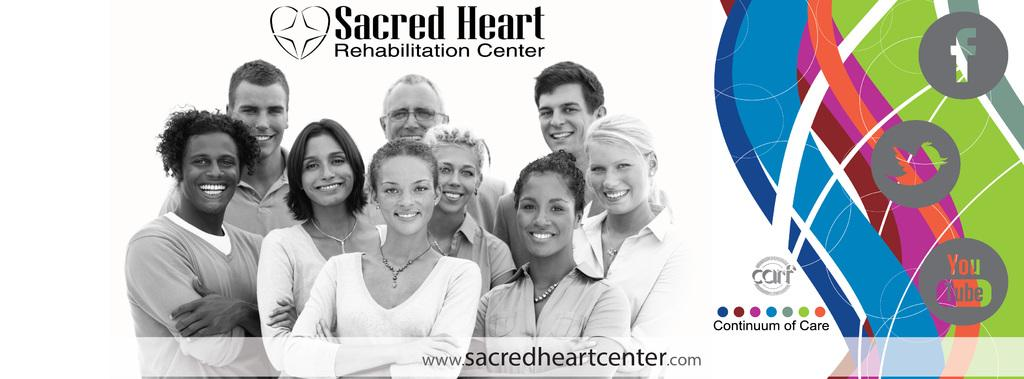What is the main object in the image? There is a poster in the image. What are the people in the poster doing? In the center of the poster, there are people standing and smiling. Where is the text located on the poster? There is text at the top and bottom of the poster. What type of religious ceremony is taking place in the image? There is no religious ceremony present in the image; it features a poster with people standing and smiling. How many calculators can be seen in the image? There are no calculators present in the image. 